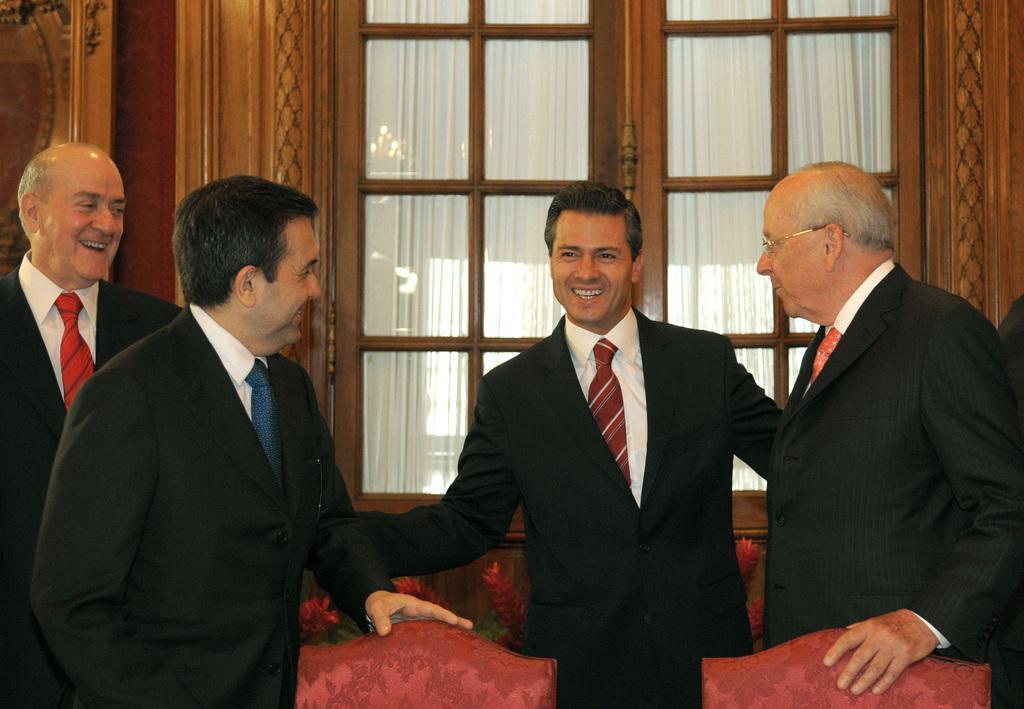Could you give a brief overview of what you see in this image? In this image there are four people wearing black suit and smiling. There there are few chairs in the room. In the background there is a glass window and white curtain. 